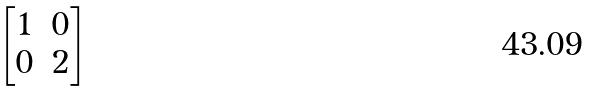Convert formula to latex. <formula><loc_0><loc_0><loc_500><loc_500>\begin{bmatrix} { 1 } & 0 \\ 0 & { 2 } \end{bmatrix}</formula> 